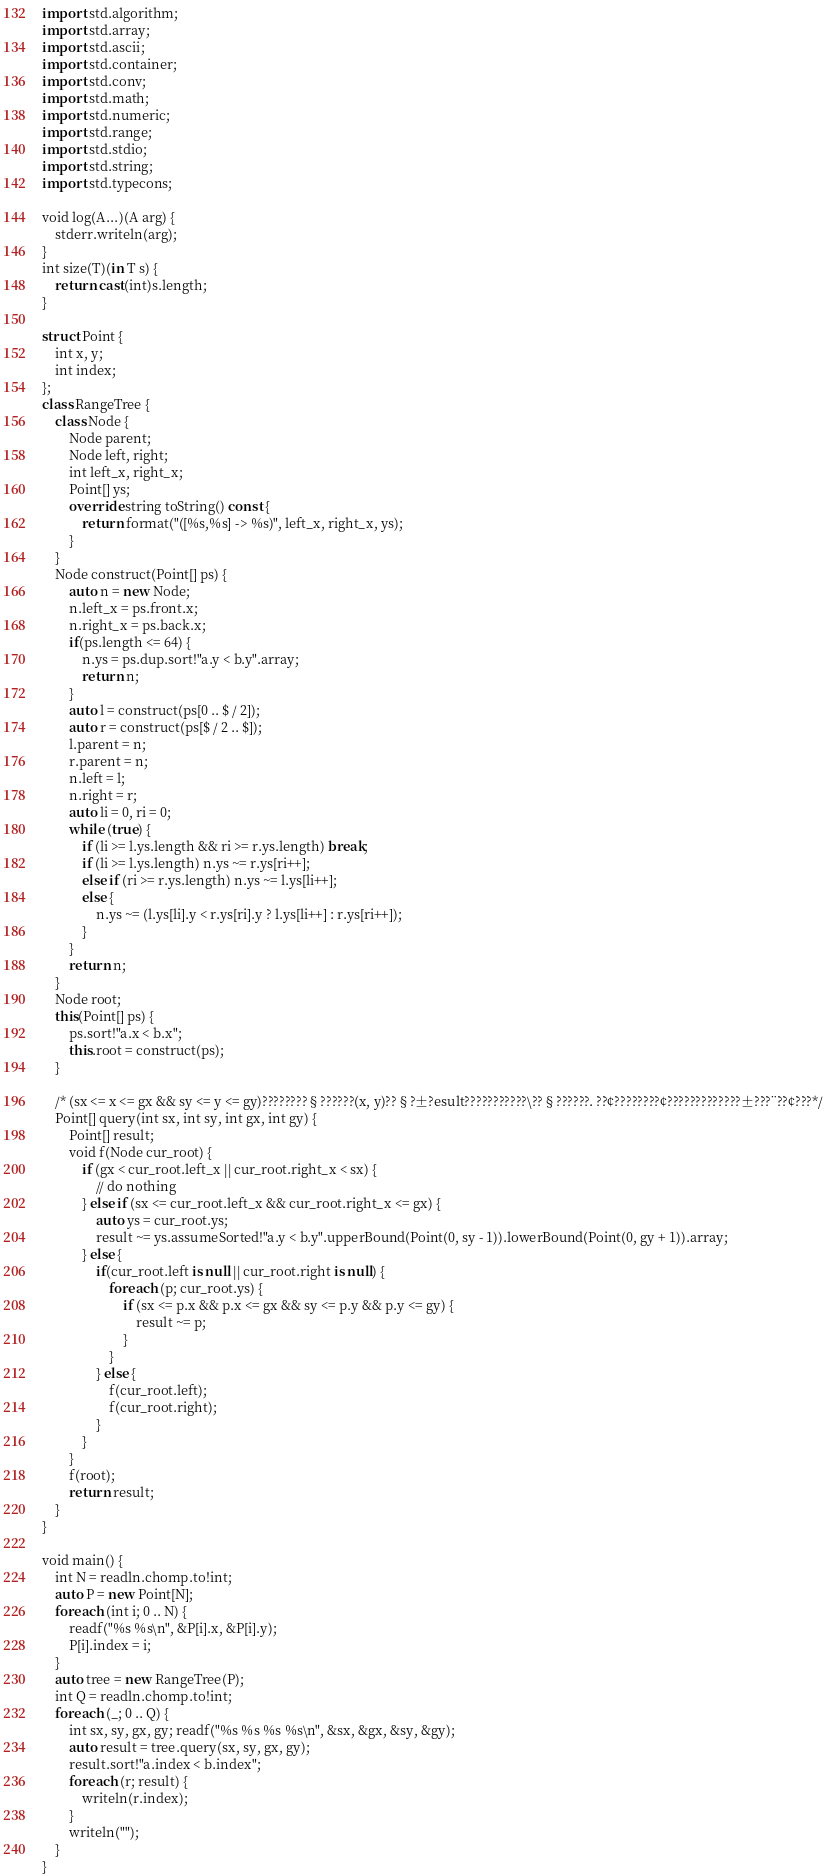Convert code to text. <code><loc_0><loc_0><loc_500><loc_500><_D_>import std.algorithm;
import std.array;
import std.ascii;
import std.container;
import std.conv;
import std.math;
import std.numeric;
import std.range;
import std.stdio;
import std.string;
import std.typecons;

void log(A...)(A arg) {
    stderr.writeln(arg);
}
int size(T)(in T s) {
    return cast(int)s.length;
}

struct Point {
    int x, y;
    int index;
};
class RangeTree {
    class Node {
        Node parent;
        Node left, right;
        int left_x, right_x;
        Point[] ys;
        override string toString() const {
            return format("([%s,%s] -> %s)", left_x, right_x, ys);
        }
    }
    Node construct(Point[] ps) {
        auto n = new Node;
        n.left_x = ps.front.x;
        n.right_x = ps.back.x;
        if(ps.length <= 64) {
            n.ys = ps.dup.sort!"a.y < b.y".array;
            return n;
        }
        auto l = construct(ps[0 .. $ / 2]);
        auto r = construct(ps[$ / 2 .. $]);
        l.parent = n;
        r.parent = n;
        n.left = l;
        n.right = r;
        auto li = 0, ri = 0;
        while (true) {
            if (li >= l.ys.length && ri >= r.ys.length) break;
            if (li >= l.ys.length) n.ys ~= r.ys[ri++];
            else if (ri >= r.ys.length) n.ys ~= l.ys[li++];
            else {
                n.ys ~= (l.ys[li].y < r.ys[ri].y ? l.ys[li++] : r.ys[ri++]);
            }
        }
        return n;
    }
    Node root;
    this(Point[] ps) {
        ps.sort!"a.x < b.x";
        this.root = construct(ps);
    }

    /* (sx <= x <= gx && sy <= y <= gy)????????§??????(x, y)??§?±?esult???????????\??§??????. ??¢????????¢?????????????±???¨??¢???*/
    Point[] query(int sx, int sy, int gx, int gy) {
        Point[] result;
        void f(Node cur_root) {
            if (gx < cur_root.left_x || cur_root.right_x < sx) {
                // do nothing
            } else if (sx <= cur_root.left_x && cur_root.right_x <= gx) {
                auto ys = cur_root.ys;
                result ~= ys.assumeSorted!"a.y < b.y".upperBound(Point(0, sy - 1)).lowerBound(Point(0, gy + 1)).array;
            } else {
                if(cur_root.left is null || cur_root.right is null) {
                    foreach (p; cur_root.ys) {
                        if (sx <= p.x && p.x <= gx && sy <= p.y && p.y <= gy) {
                            result ~= p;
                        }
                    }
                } else {
                    f(cur_root.left);
                    f(cur_root.right);
                }
            }
        }
        f(root);
        return result;
    }
}

void main() {
    int N = readln.chomp.to!int;
    auto P = new Point[N];
    foreach (int i; 0 .. N) {
        readf("%s %s\n", &P[i].x, &P[i].y);
        P[i].index = i;
    }
    auto tree = new RangeTree(P);
    int Q = readln.chomp.to!int;
    foreach (_; 0 .. Q) {
        int sx, sy, gx, gy; readf("%s %s %s %s\n", &sx, &gx, &sy, &gy);
        auto result = tree.query(sx, sy, gx, gy);
        result.sort!"a.index < b.index";
        foreach (r; result) {
            writeln(r.index);
        }
        writeln("");
    }
}</code> 